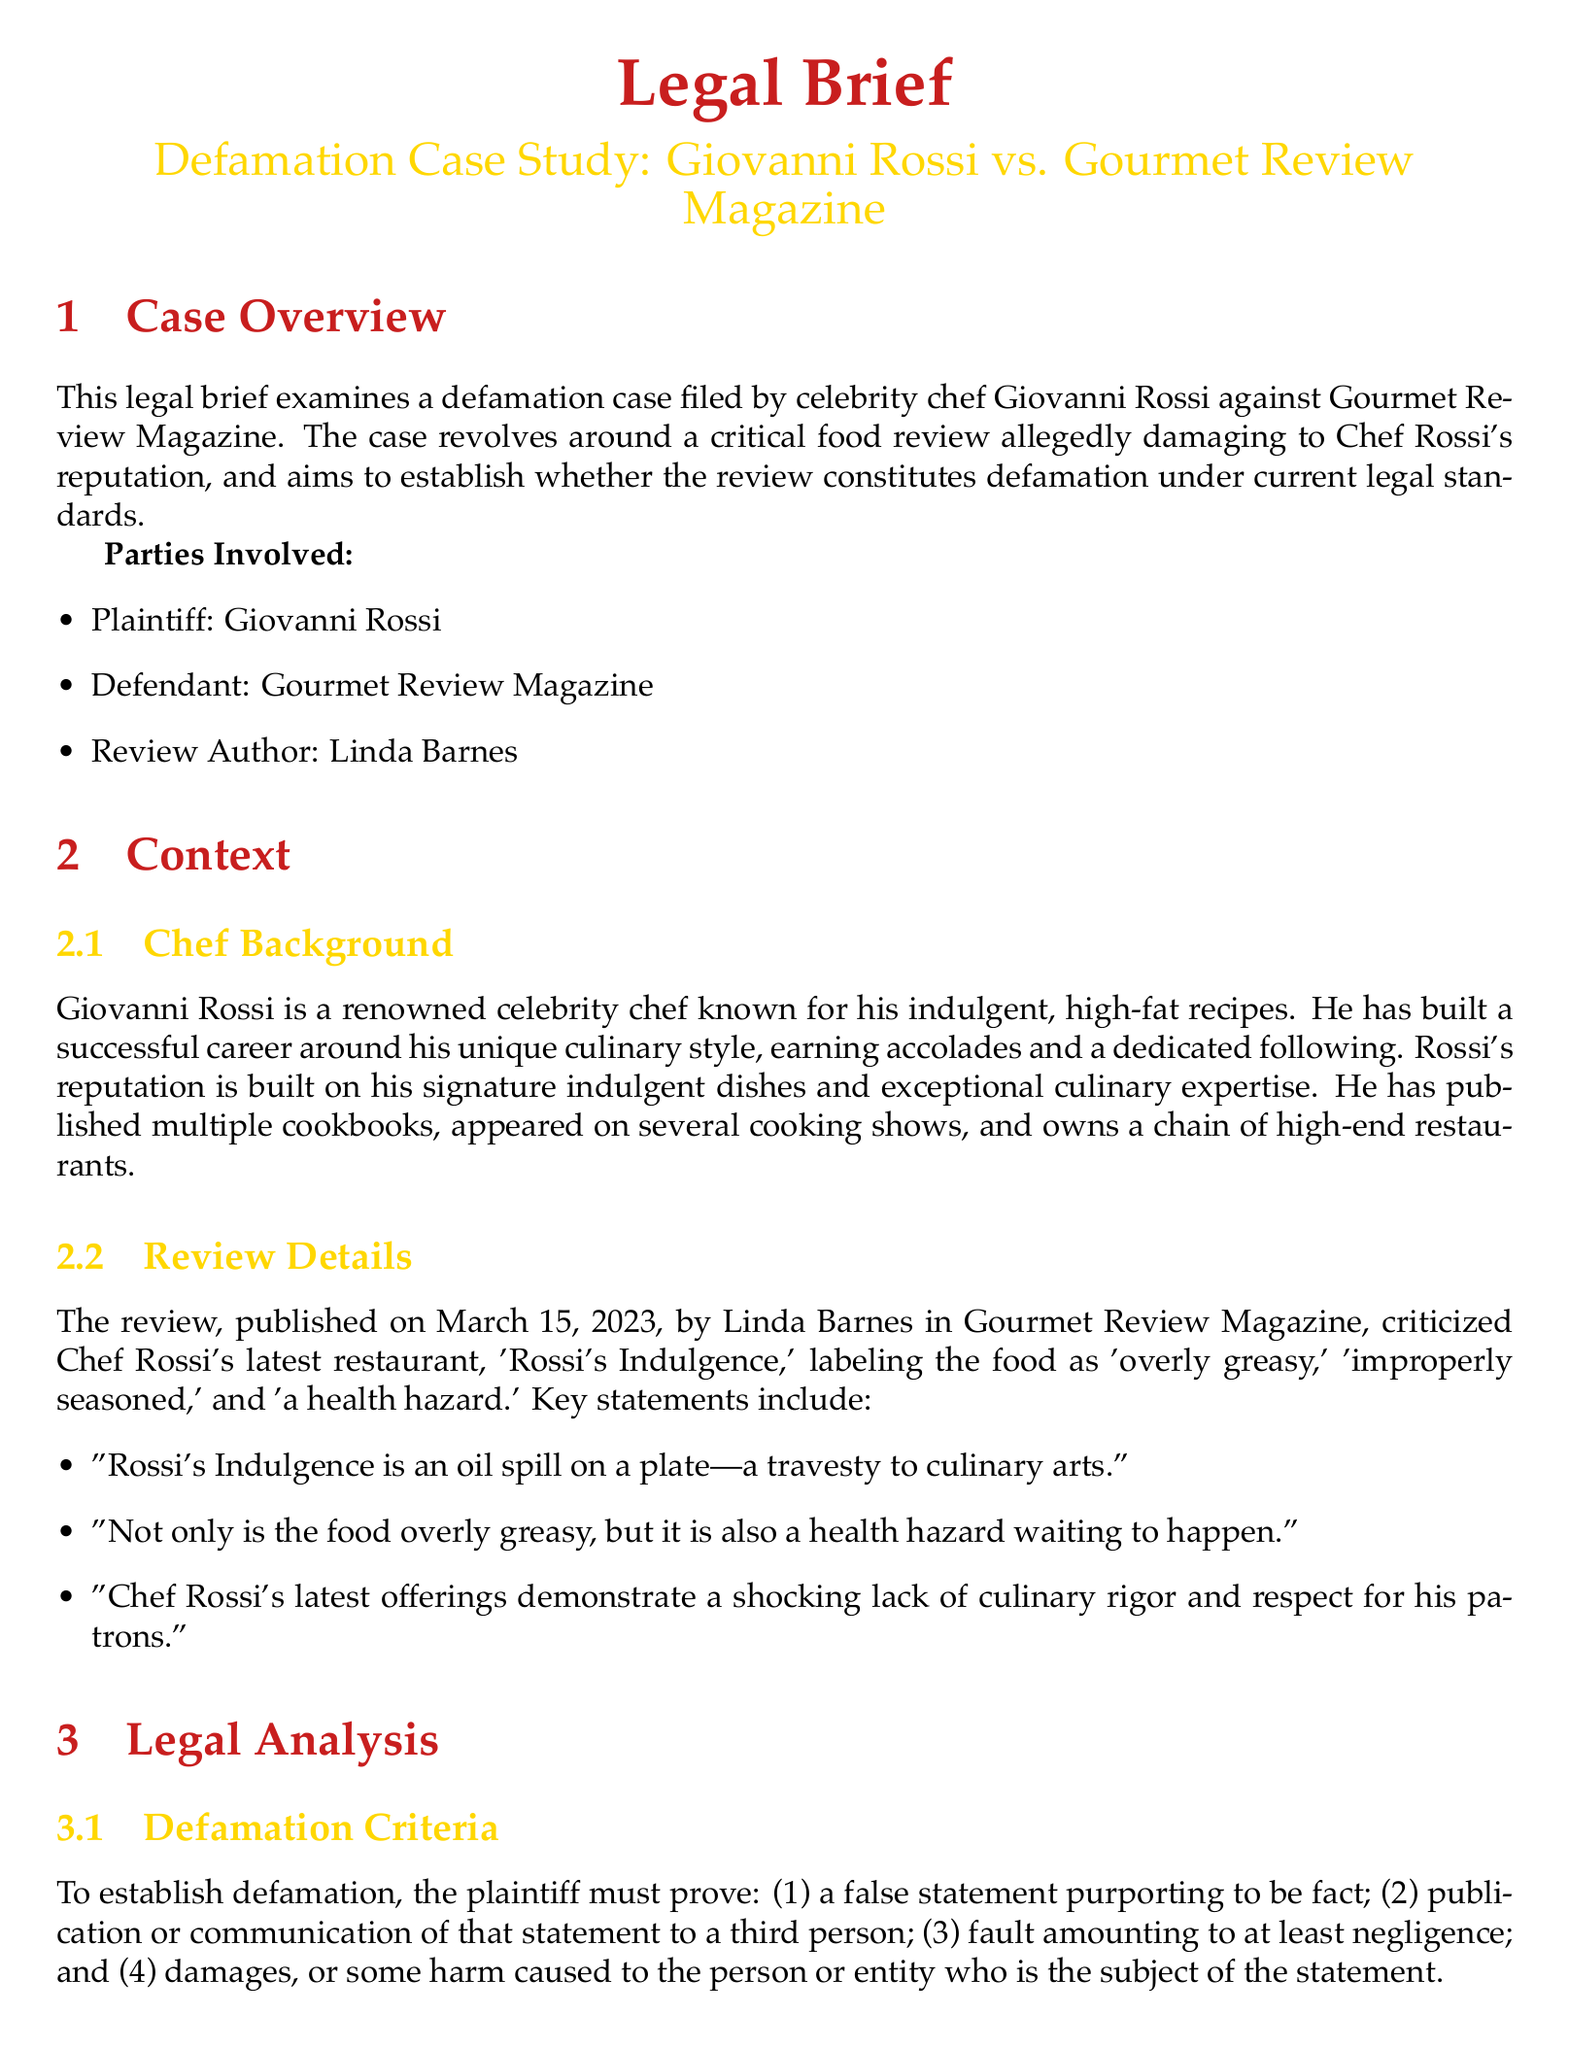What is the name of the plaintiff? The plaintiff in the case is identified as Giovanni Rossi.
Answer: Giovanni Rossi Who authored the critical review? The review was written by Linda Barnes, as mentioned in the document.
Answer: Linda Barnes What allegations were made against Rossi's restaurant? The review claims the food is 'overly greasy,' 'improperly seasoned,' and 'a health hazard.'
Answer: Overly greasy, improperly seasoned, health hazard On what date was the review published? The review was published on March 15, 2023, which is specified in the review details.
Answer: March 15, 2023 What type of defense is claimed by Gourmet Review Magazine? The magazine argues that the review constitutes opinion and rhetorical hyperbole.
Answer: Opinion defense What does Rossi claim as the consequence of the review? Rossi states that the review led to a decline in restaurant reservations and financial losses.
Answer: Decline in restaurant reservations, financial losses What must the plaintiff prove to establish defamation? The criteria include a false statement, publication, fault, and damages.
Answer: False statement, publication, fault, damages What does the defense argue regarding the truth of the statements? The defense asserts that the statements about the food being 'overly greasy' and 'improperly seasoned' are truthful or substantially truthful.
Answer: Truth defense 